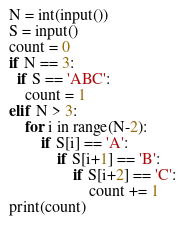<code> <loc_0><loc_0><loc_500><loc_500><_Python_>N = int(input())
S = input()
count = 0
if N == 3:
  if S == 'ABC':
    count = 1
elif N > 3:
	for i in range(N-2):
		if S[i] == 'A':
			if S[i+1] == 'B':
				if S[i+2] == 'C':
					count += 1
print(count)
</code> 